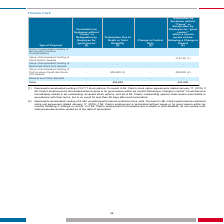From Systemax's financial document, What are the Thomas Clark's accelerated vesting of stock options and unvested performance restricted stock units respectively? The document shows two values: 33,711 and 8,340. From the document: "(1) Represents accelerated vesting of 33,711 stock options. Pursuant to Mr. Clark’s stock option agreements (dated January 17, 2019), if (1) Represent..." Also, What is the total termination due to Thomas Clark as a result of death or termination by Systemax without cause respectively? The document shows two values: 209,800 and 523,900. From the document: "Total - 209,800 - 523,900 Total - 209,800 - 523,900..." Also, What is the value of Thomas Clark's medical and other benefits and Accelerated Vesting of Stock Option Awards respectively? The document shows two values: 0 and 0. From the document: "lerated Vesting of Stock Option Awards - - - 314,100 (1)..." Also, can you calculate: What is the value of accelerated vesting of stock option awards as a percentage of the total payments made as a result of termination by Systemax without cause within a certain period of time following a Change in Control? Based on the calculation: 314,100/523,900 , the result is 59.95 (percentage). This is based on the information: "Accelerated Vesting of Stock Option Awards - - - 314,100 (1) Total - 209,800 - 523,900..." The key data points involved are: 314,100, 523,900. Also, can you calculate: What is the total termination due to Thomas Clark as a result of death or termination by Systemax without cause within a certain period of time following a Change in Control? Based on the calculation: 209,800 + 523,900 , the result is 733700. This is based on the information: "Total - 209,800 - 523,900 Total - 209,800 - 523,900..." The key data points involved are: 209,800, 523,900. Also, can you calculate: What is the proportion of total payment as a result of termination due to death as a percentage of the overall payment due to Thomas Clark? To answer this question, I need to perform calculations using the financial data. The calculation is: 209,800/ (209,800 + 523,900) , which equals 28.59 (percentage). This is based on the information: "Total - 209,800 - 523,900 Total - 209,800 - 523,900..." The key data points involved are: 209,800, 523,900. 